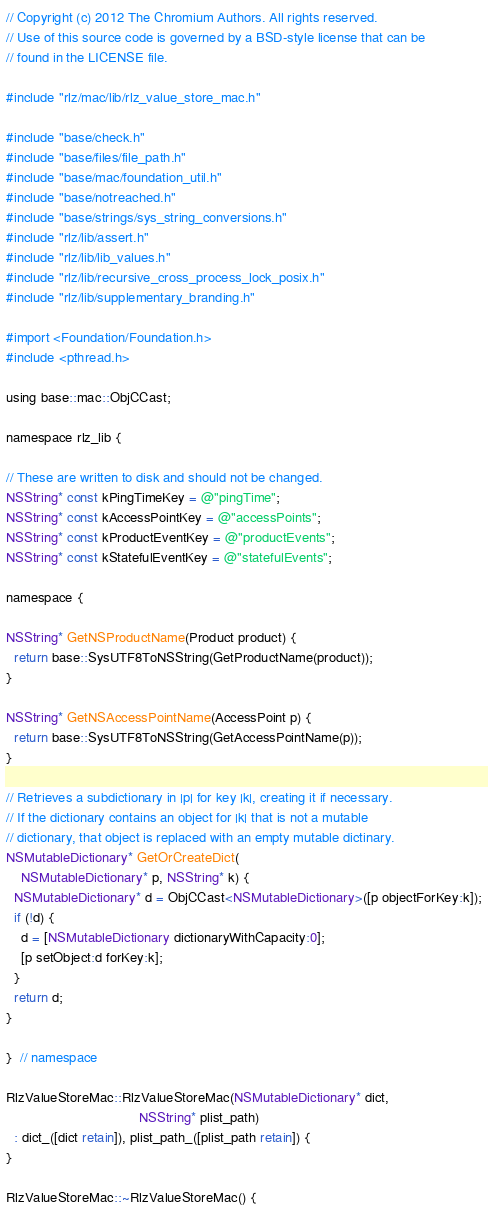Convert code to text. <code><loc_0><loc_0><loc_500><loc_500><_ObjectiveC_>// Copyright (c) 2012 The Chromium Authors. All rights reserved.
// Use of this source code is governed by a BSD-style license that can be
// found in the LICENSE file.

#include "rlz/mac/lib/rlz_value_store_mac.h"

#include "base/check.h"
#include "base/files/file_path.h"
#include "base/mac/foundation_util.h"
#include "base/notreached.h"
#include "base/strings/sys_string_conversions.h"
#include "rlz/lib/assert.h"
#include "rlz/lib/lib_values.h"
#include "rlz/lib/recursive_cross_process_lock_posix.h"
#include "rlz/lib/supplementary_branding.h"

#import <Foundation/Foundation.h>
#include <pthread.h>

using base::mac::ObjCCast;

namespace rlz_lib {

// These are written to disk and should not be changed.
NSString* const kPingTimeKey = @"pingTime";
NSString* const kAccessPointKey = @"accessPoints";
NSString* const kProductEventKey = @"productEvents";
NSString* const kStatefulEventKey = @"statefulEvents";

namespace {

NSString* GetNSProductName(Product product) {
  return base::SysUTF8ToNSString(GetProductName(product));
}

NSString* GetNSAccessPointName(AccessPoint p) {
  return base::SysUTF8ToNSString(GetAccessPointName(p));
}

// Retrieves a subdictionary in |p| for key |k|, creating it if necessary.
// If the dictionary contains an object for |k| that is not a mutable
// dictionary, that object is replaced with an empty mutable dictinary.
NSMutableDictionary* GetOrCreateDict(
    NSMutableDictionary* p, NSString* k) {
  NSMutableDictionary* d = ObjCCast<NSMutableDictionary>([p objectForKey:k]);
  if (!d) {
    d = [NSMutableDictionary dictionaryWithCapacity:0];
    [p setObject:d forKey:k];
  }
  return d;
}

}  // namespace

RlzValueStoreMac::RlzValueStoreMac(NSMutableDictionary* dict,
                                   NSString* plist_path)
  : dict_([dict retain]), plist_path_([plist_path retain]) {
}

RlzValueStoreMac::~RlzValueStoreMac() {</code> 